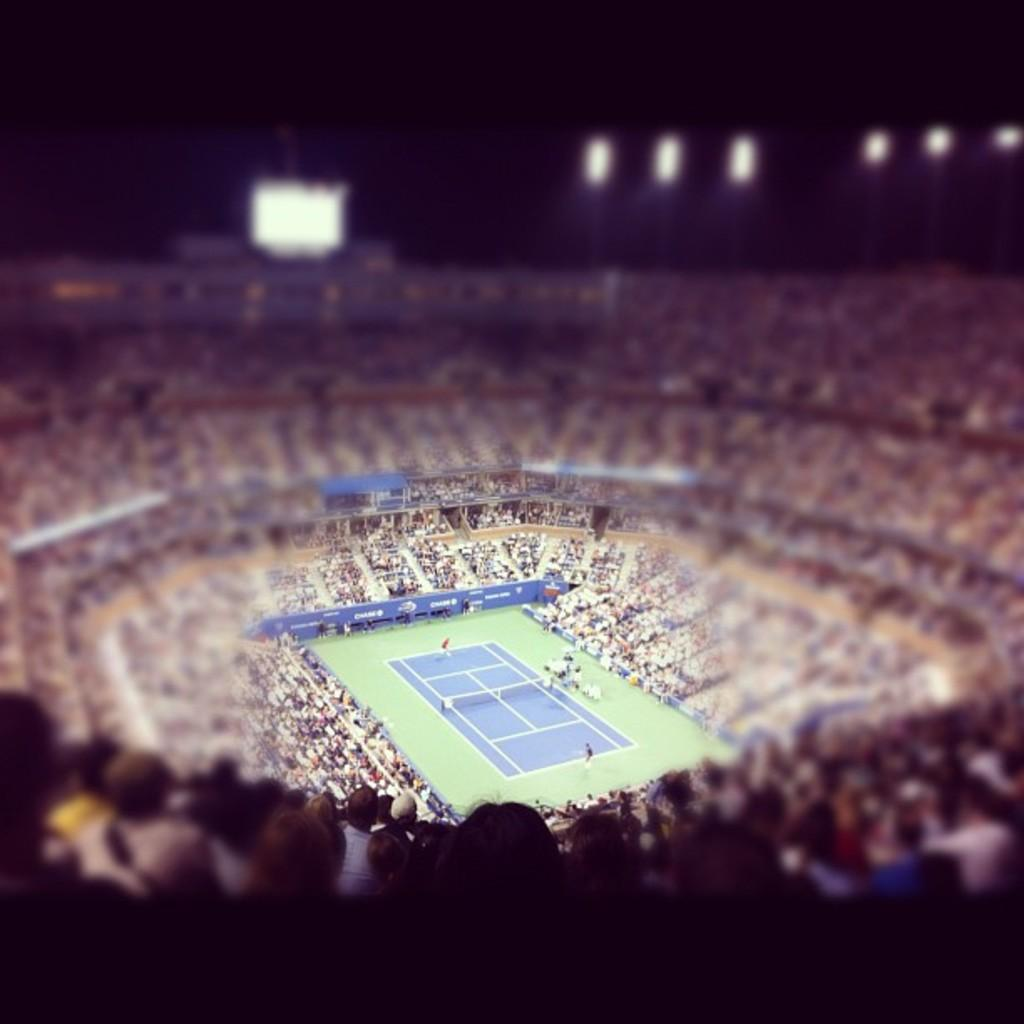What type of location is depicted in the image? The image is a view from a stadium. Can you describe the people visible in the image? There are people visible in the image. What other objects can be seen in the image besides people? There are posters and lights present in the image. What is the condition of the ground in the image? The ground is visible in the image. How is the background of the image depicted? The background of the image is blurred. What type of table is visible in the image? There is no table present in the image. Can you describe the fog in the image? There is no fog present in the image. 